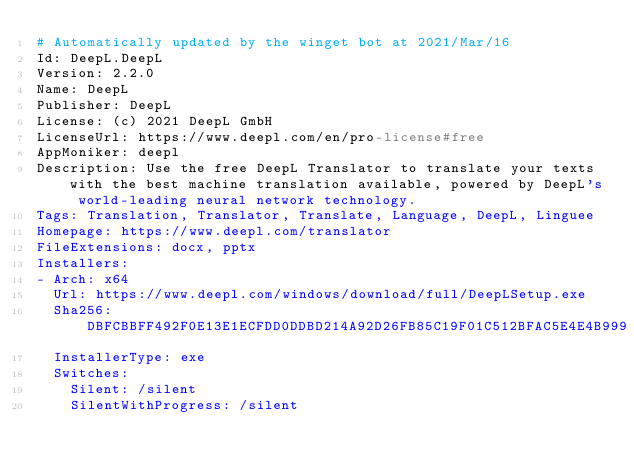Convert code to text. <code><loc_0><loc_0><loc_500><loc_500><_YAML_># Automatically updated by the winget bot at 2021/Mar/16
Id: DeepL.DeepL
Version: 2.2.0
Name: DeepL
Publisher: DeepL
License: (c) 2021 DeepL GmbH
LicenseUrl: https://www.deepl.com/en/pro-license#free
AppMoniker: deepl
Description: Use the free DeepL Translator to translate your texts with the best machine translation available, powered by DeepL's world-leading neural network technology.
Tags: Translation, Translator, Translate, Language, DeepL, Linguee
Homepage: https://www.deepl.com/translator
FileExtensions: docx, pptx
Installers:
- Arch: x64
  Url: https://www.deepl.com/windows/download/full/DeepLSetup.exe
  Sha256: DBFCBBFF492F0E13E1ECFDD0DDBD214A92D26FB85C19F01C512BFAC5E4E4B999
  InstallerType: exe
  Switches:
    Silent: /silent
    SilentWithProgress: /silent
</code> 